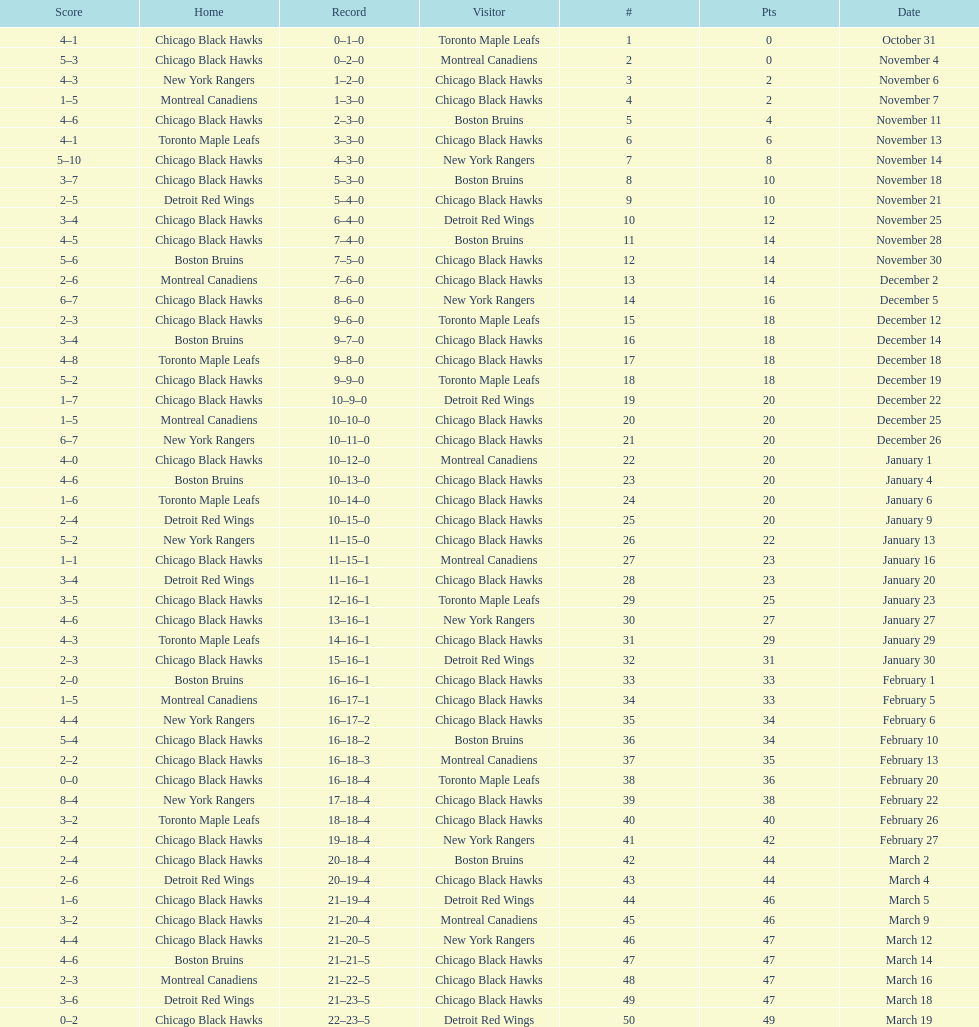What was the total amount of points scored on november 4th? 8. 